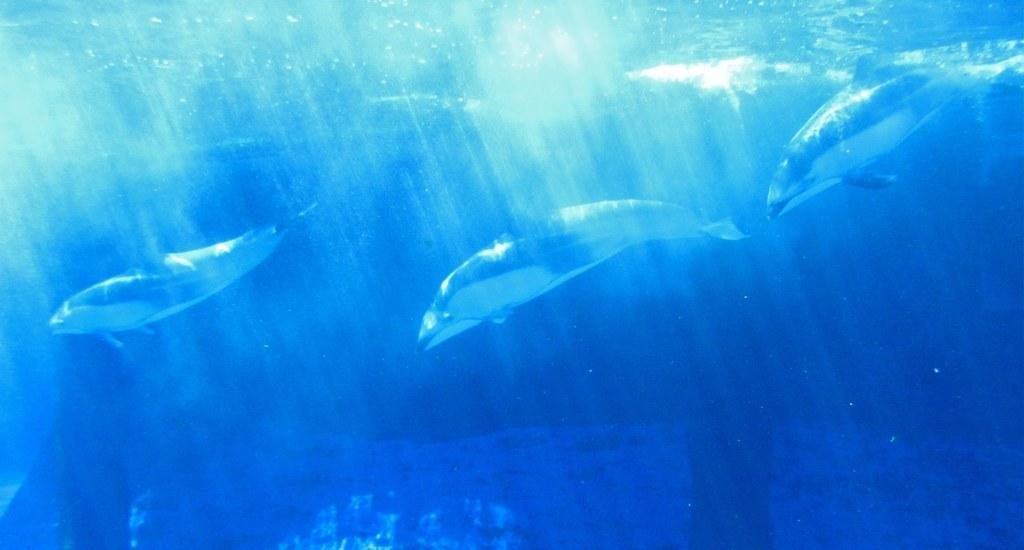How many fish can be seen in the image? There are three fish in the image. Where are the fish located? The fish are present in the water. What type of feast is being prepared by the fish in the image? There is no feast being prepared by the fish in the image, as they are simply present in the water. 